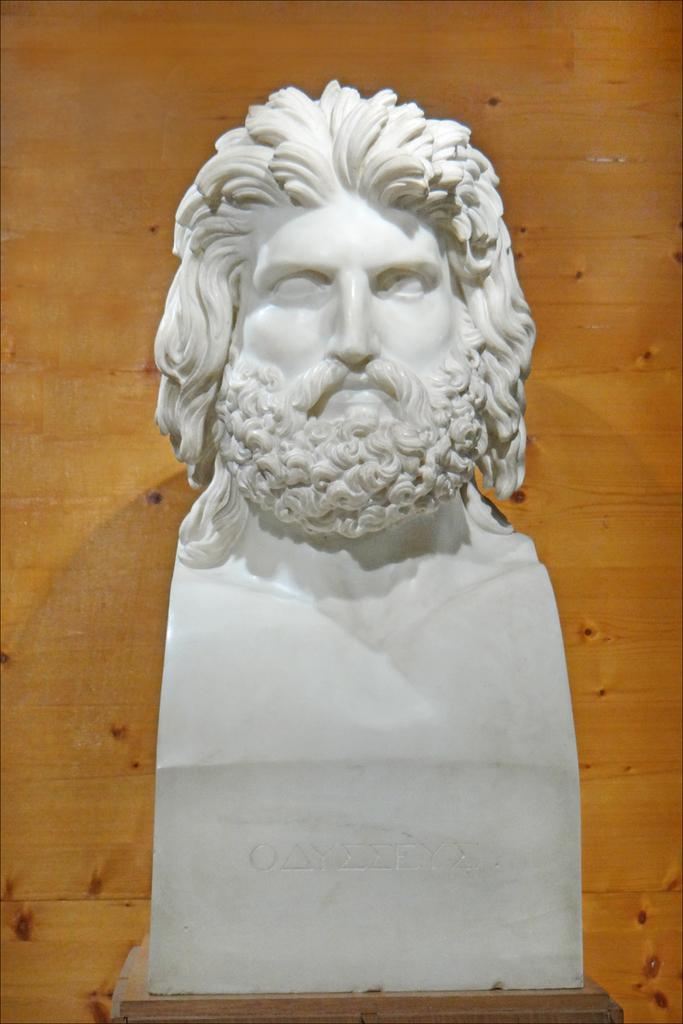What is the main subject of the image? There is a sculpture of a person in the image. Can you describe the background of the image? There is a wooden wall in the background of the image. What level of experience does the beginner have with the sculpture in the image? There is no information about a beginner or their experience with the sculpture in the image. 